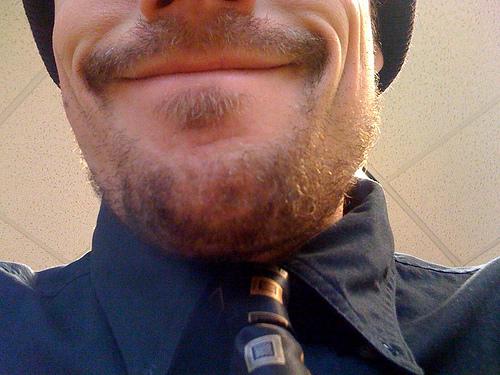Is he wearing a tie?
Concise answer only. Yes. Is he smiling?
Answer briefly. Yes. What does the person have on his head?
Write a very short answer. Hat. 